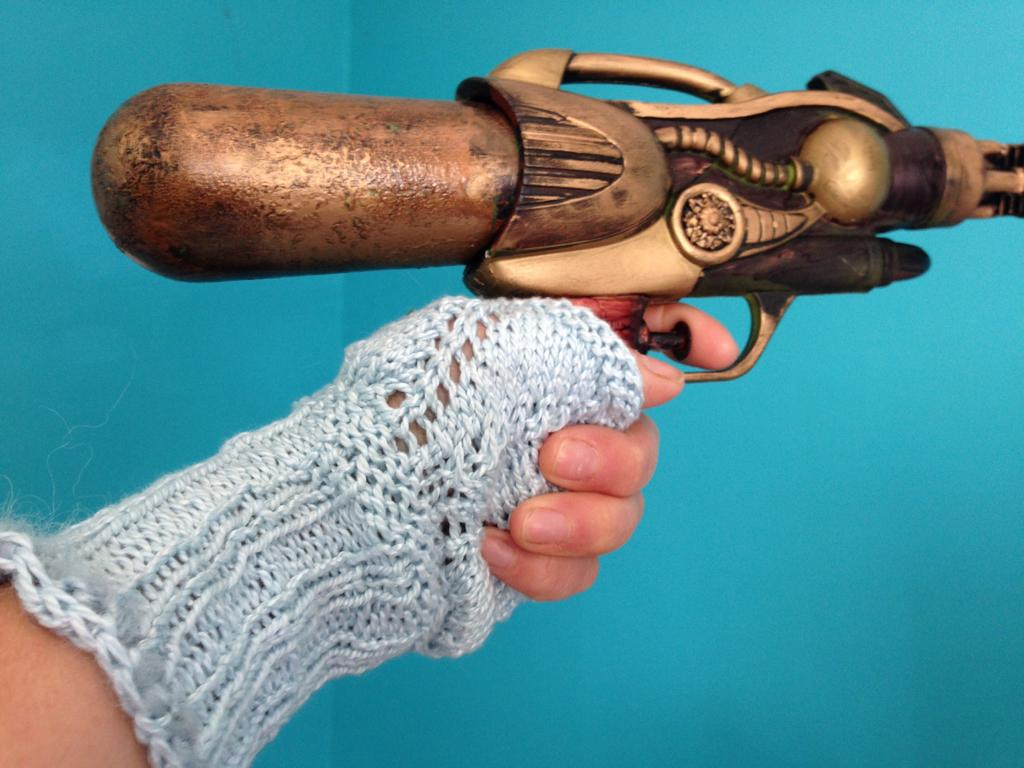What is the main object in the center of the image? There is a gun in the center of the image. Can you describe the person on the left side of the image? There is a girl standing on the left side of the image. What type of duck can be seen swimming in the water in the image? There is no duck or water present in the image; it only features a gun and a girl. 